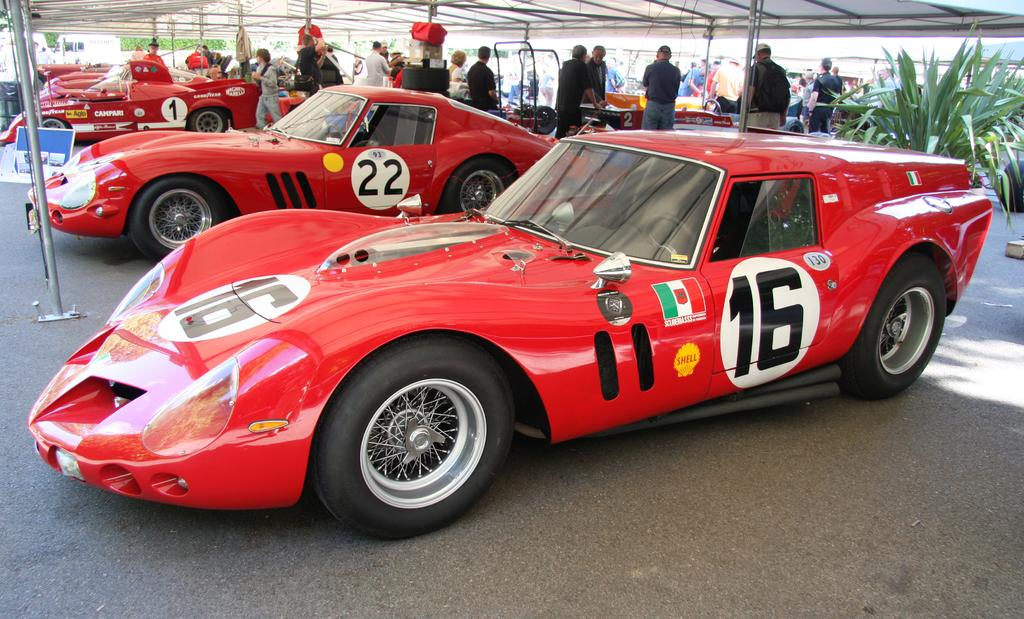What type of structure is visible in the image? There is an open shed in the image. What is located under the shed? There are vehicles under the shed. What can be seen supporting the shed or other structures in the image? There are poles in the image. Are there any people present in the image? Yes, there are people in the image. What type of plant is visible in the image? There is a plant in the image. Can you describe any other unspecified objects or features in the image? There are other unspecified things in the image. What is visible in the distance in the image? There is a tree visible in the distance. What type of smoke can be seen coming from the division on the pump in the image? There is no pump or smoke present in the image. 